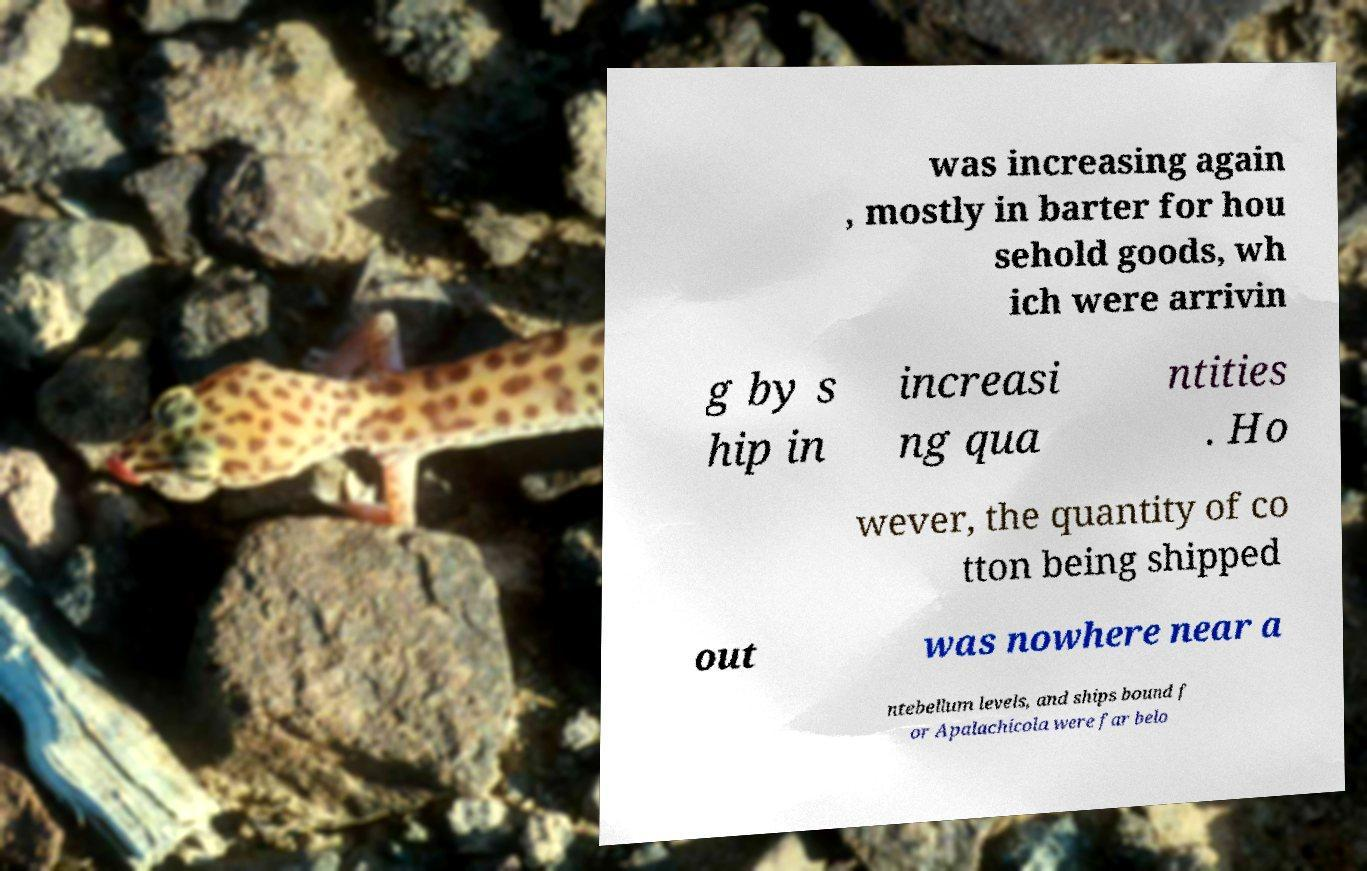Please identify and transcribe the text found in this image. was increasing again , mostly in barter for hou sehold goods, wh ich were arrivin g by s hip in increasi ng qua ntities . Ho wever, the quantity of co tton being shipped out was nowhere near a ntebellum levels, and ships bound f or Apalachicola were far belo 